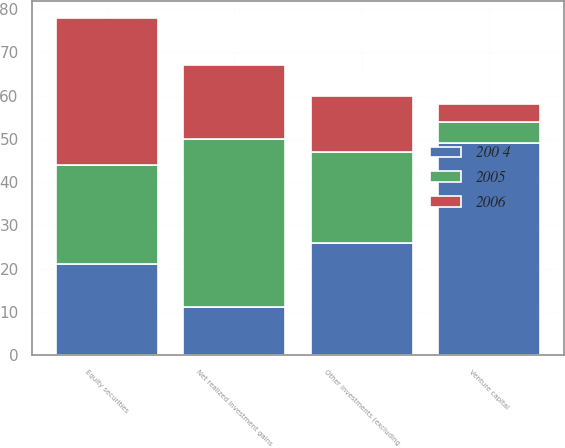<chart> <loc_0><loc_0><loc_500><loc_500><stacked_bar_chart><ecel><fcel>Equity securities<fcel>Venture capital<fcel>Other investments (excluding<fcel>Net realized investment gains<nl><fcel>200 4<fcel>21<fcel>49<fcel>26<fcel>11<nl><fcel>2006<fcel>34<fcel>4<fcel>13<fcel>17<nl><fcel>2005<fcel>23<fcel>5<fcel>21<fcel>39<nl></chart> 